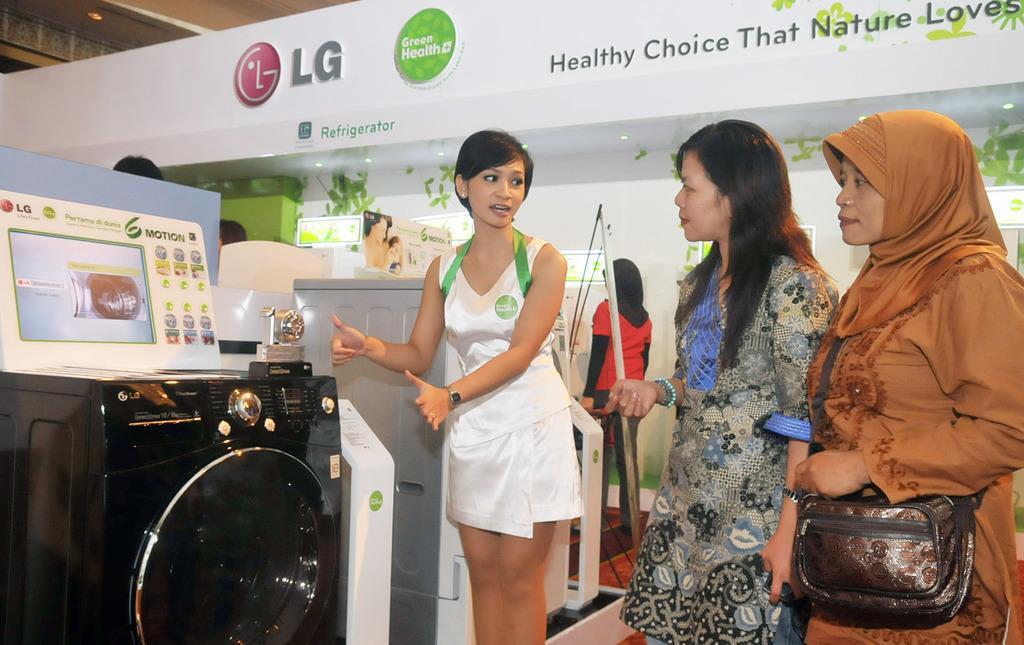How would you summarize this image in a sentence or two? There is a group of women standing on the right side of this image. We can see a washing machine and other objects are present on the left side of this image. We can see logos and text present at the top of this image. 